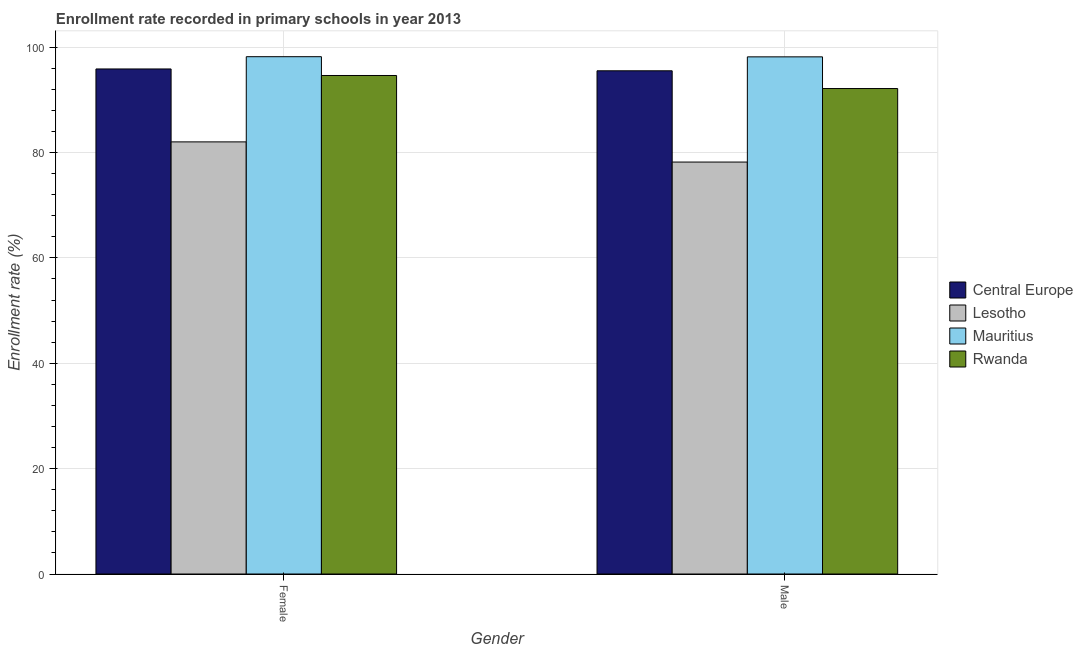What is the label of the 2nd group of bars from the left?
Offer a terse response. Male. What is the enrollment rate of male students in Mauritius?
Keep it short and to the point. 98.16. Across all countries, what is the maximum enrollment rate of male students?
Give a very brief answer. 98.16. Across all countries, what is the minimum enrollment rate of female students?
Your answer should be compact. 82.02. In which country was the enrollment rate of female students maximum?
Your answer should be compact. Mauritius. In which country was the enrollment rate of male students minimum?
Give a very brief answer. Lesotho. What is the total enrollment rate of male students in the graph?
Your answer should be very brief. 364.02. What is the difference between the enrollment rate of male students in Central Europe and that in Mauritius?
Offer a very short reply. -2.65. What is the difference between the enrollment rate of female students in Lesotho and the enrollment rate of male students in Central Europe?
Provide a succinct answer. -13.49. What is the average enrollment rate of female students per country?
Your answer should be compact. 92.68. What is the difference between the enrollment rate of male students and enrollment rate of female students in Lesotho?
Provide a succinct answer. -3.83. In how many countries, is the enrollment rate of female students greater than 12 %?
Your response must be concise. 4. What is the ratio of the enrollment rate of female students in Mauritius to that in Rwanda?
Make the answer very short. 1.04. Is the enrollment rate of female students in Lesotho less than that in Rwanda?
Provide a short and direct response. Yes. What does the 1st bar from the left in Female represents?
Ensure brevity in your answer.  Central Europe. What does the 2nd bar from the right in Male represents?
Provide a succinct answer. Mauritius. How many countries are there in the graph?
Provide a succinct answer. 4. What is the difference between two consecutive major ticks on the Y-axis?
Ensure brevity in your answer.  20. Where does the legend appear in the graph?
Offer a terse response. Center right. What is the title of the graph?
Offer a terse response. Enrollment rate recorded in primary schools in year 2013. Does "France" appear as one of the legend labels in the graph?
Offer a very short reply. No. What is the label or title of the Y-axis?
Ensure brevity in your answer.  Enrollment rate (%). What is the Enrollment rate (%) of Central Europe in Female?
Keep it short and to the point. 95.87. What is the Enrollment rate (%) in Lesotho in Female?
Your answer should be compact. 82.02. What is the Enrollment rate (%) of Mauritius in Female?
Ensure brevity in your answer.  98.19. What is the Enrollment rate (%) in Rwanda in Female?
Provide a succinct answer. 94.62. What is the Enrollment rate (%) of Central Europe in Male?
Provide a short and direct response. 95.52. What is the Enrollment rate (%) in Lesotho in Male?
Provide a short and direct response. 78.19. What is the Enrollment rate (%) in Mauritius in Male?
Offer a terse response. 98.16. What is the Enrollment rate (%) of Rwanda in Male?
Offer a terse response. 92.15. Across all Gender, what is the maximum Enrollment rate (%) in Central Europe?
Ensure brevity in your answer.  95.87. Across all Gender, what is the maximum Enrollment rate (%) in Lesotho?
Make the answer very short. 82.02. Across all Gender, what is the maximum Enrollment rate (%) of Mauritius?
Ensure brevity in your answer.  98.19. Across all Gender, what is the maximum Enrollment rate (%) in Rwanda?
Keep it short and to the point. 94.62. Across all Gender, what is the minimum Enrollment rate (%) of Central Europe?
Ensure brevity in your answer.  95.52. Across all Gender, what is the minimum Enrollment rate (%) in Lesotho?
Ensure brevity in your answer.  78.19. Across all Gender, what is the minimum Enrollment rate (%) of Mauritius?
Make the answer very short. 98.16. Across all Gender, what is the minimum Enrollment rate (%) of Rwanda?
Your answer should be compact. 92.15. What is the total Enrollment rate (%) of Central Europe in the graph?
Your answer should be very brief. 191.38. What is the total Enrollment rate (%) of Lesotho in the graph?
Your response must be concise. 160.22. What is the total Enrollment rate (%) in Mauritius in the graph?
Your answer should be very brief. 196.36. What is the total Enrollment rate (%) in Rwanda in the graph?
Keep it short and to the point. 186.77. What is the difference between the Enrollment rate (%) in Central Europe in Female and that in Male?
Give a very brief answer. 0.35. What is the difference between the Enrollment rate (%) in Lesotho in Female and that in Male?
Provide a short and direct response. 3.83. What is the difference between the Enrollment rate (%) of Mauritius in Female and that in Male?
Make the answer very short. 0.03. What is the difference between the Enrollment rate (%) of Rwanda in Female and that in Male?
Provide a short and direct response. 2.48. What is the difference between the Enrollment rate (%) of Central Europe in Female and the Enrollment rate (%) of Lesotho in Male?
Your response must be concise. 17.67. What is the difference between the Enrollment rate (%) of Central Europe in Female and the Enrollment rate (%) of Mauritius in Male?
Provide a short and direct response. -2.3. What is the difference between the Enrollment rate (%) in Central Europe in Female and the Enrollment rate (%) in Rwanda in Male?
Your answer should be very brief. 3.72. What is the difference between the Enrollment rate (%) in Lesotho in Female and the Enrollment rate (%) in Mauritius in Male?
Your answer should be compact. -16.14. What is the difference between the Enrollment rate (%) of Lesotho in Female and the Enrollment rate (%) of Rwanda in Male?
Give a very brief answer. -10.12. What is the difference between the Enrollment rate (%) of Mauritius in Female and the Enrollment rate (%) of Rwanda in Male?
Provide a short and direct response. 6.05. What is the average Enrollment rate (%) of Central Europe per Gender?
Offer a terse response. 95.69. What is the average Enrollment rate (%) of Lesotho per Gender?
Provide a succinct answer. 80.11. What is the average Enrollment rate (%) in Mauritius per Gender?
Offer a terse response. 98.18. What is the average Enrollment rate (%) in Rwanda per Gender?
Your answer should be compact. 93.39. What is the difference between the Enrollment rate (%) in Central Europe and Enrollment rate (%) in Lesotho in Female?
Offer a terse response. 13.84. What is the difference between the Enrollment rate (%) in Central Europe and Enrollment rate (%) in Mauritius in Female?
Provide a short and direct response. -2.33. What is the difference between the Enrollment rate (%) in Central Europe and Enrollment rate (%) in Rwanda in Female?
Make the answer very short. 1.24. What is the difference between the Enrollment rate (%) in Lesotho and Enrollment rate (%) in Mauritius in Female?
Make the answer very short. -16.17. What is the difference between the Enrollment rate (%) in Lesotho and Enrollment rate (%) in Rwanda in Female?
Offer a very short reply. -12.6. What is the difference between the Enrollment rate (%) of Mauritius and Enrollment rate (%) of Rwanda in Female?
Offer a terse response. 3.57. What is the difference between the Enrollment rate (%) in Central Europe and Enrollment rate (%) in Lesotho in Male?
Your answer should be very brief. 17.32. What is the difference between the Enrollment rate (%) of Central Europe and Enrollment rate (%) of Mauritius in Male?
Your response must be concise. -2.65. What is the difference between the Enrollment rate (%) in Central Europe and Enrollment rate (%) in Rwanda in Male?
Give a very brief answer. 3.37. What is the difference between the Enrollment rate (%) in Lesotho and Enrollment rate (%) in Mauritius in Male?
Provide a succinct answer. -19.97. What is the difference between the Enrollment rate (%) in Lesotho and Enrollment rate (%) in Rwanda in Male?
Offer a terse response. -13.95. What is the difference between the Enrollment rate (%) of Mauritius and Enrollment rate (%) of Rwanda in Male?
Offer a very short reply. 6.01. What is the ratio of the Enrollment rate (%) of Central Europe in Female to that in Male?
Ensure brevity in your answer.  1. What is the ratio of the Enrollment rate (%) in Lesotho in Female to that in Male?
Provide a succinct answer. 1.05. What is the ratio of the Enrollment rate (%) of Rwanda in Female to that in Male?
Keep it short and to the point. 1.03. What is the difference between the highest and the second highest Enrollment rate (%) of Central Europe?
Your response must be concise. 0.35. What is the difference between the highest and the second highest Enrollment rate (%) in Lesotho?
Give a very brief answer. 3.83. What is the difference between the highest and the second highest Enrollment rate (%) of Mauritius?
Provide a short and direct response. 0.03. What is the difference between the highest and the second highest Enrollment rate (%) in Rwanda?
Your response must be concise. 2.48. What is the difference between the highest and the lowest Enrollment rate (%) in Central Europe?
Provide a succinct answer. 0.35. What is the difference between the highest and the lowest Enrollment rate (%) of Lesotho?
Make the answer very short. 3.83. What is the difference between the highest and the lowest Enrollment rate (%) of Mauritius?
Offer a very short reply. 0.03. What is the difference between the highest and the lowest Enrollment rate (%) in Rwanda?
Your response must be concise. 2.48. 